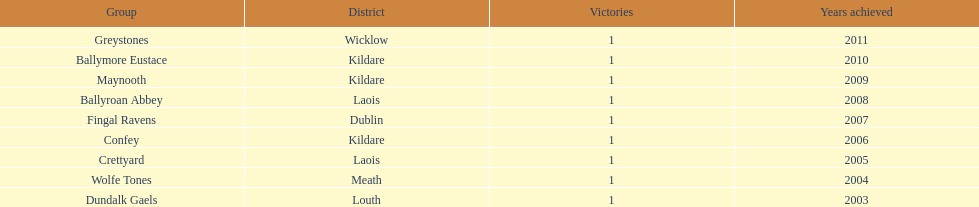What was the total number of victories for confey? 1. 